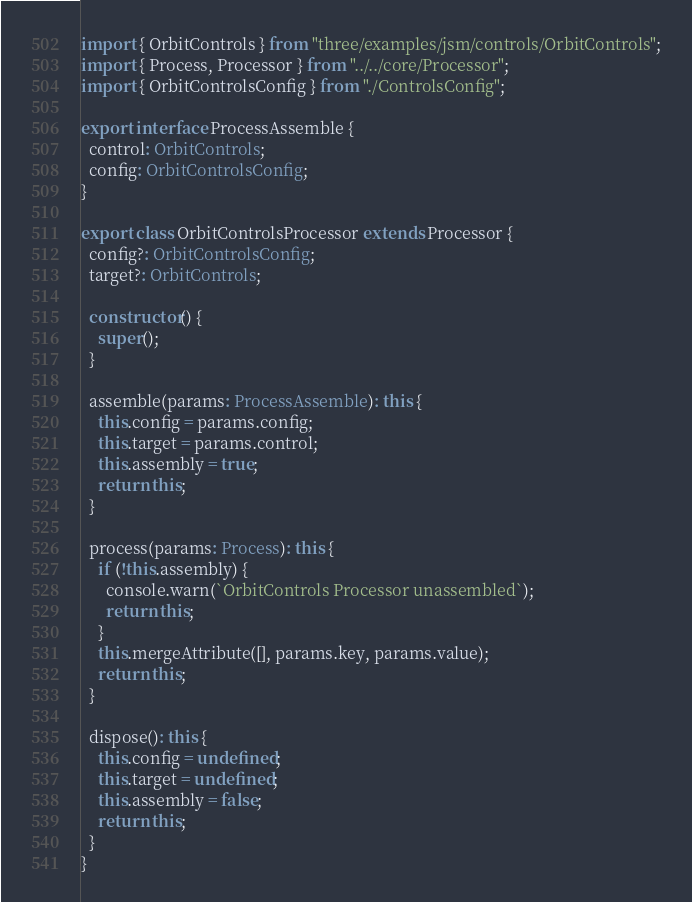<code> <loc_0><loc_0><loc_500><loc_500><_TypeScript_>import { OrbitControls } from "three/examples/jsm/controls/OrbitControls";
import { Process, Processor } from "../../core/Processor";
import { OrbitControlsConfig } from "./ControlsConfig";

export interface ProcessAssemble {
  control: OrbitControls;
  config: OrbitControlsConfig;
}

export class OrbitControlsProcessor extends Processor {
  config?: OrbitControlsConfig;
  target?: OrbitControls;

  constructor() {
    super();
  }

  assemble(params: ProcessAssemble): this {
    this.config = params.config;
    this.target = params.control;
    this.assembly = true;
    return this;
  }

  process(params: Process): this {
    if (!this.assembly) {
      console.warn(`OrbitControls Processor unassembled`);
      return this;
    }
    this.mergeAttribute([], params.key, params.value);
    return this;
  }

  dispose(): this {
    this.config = undefined;
    this.target = undefined;
    this.assembly = false;
    return this;
  }
}
</code> 